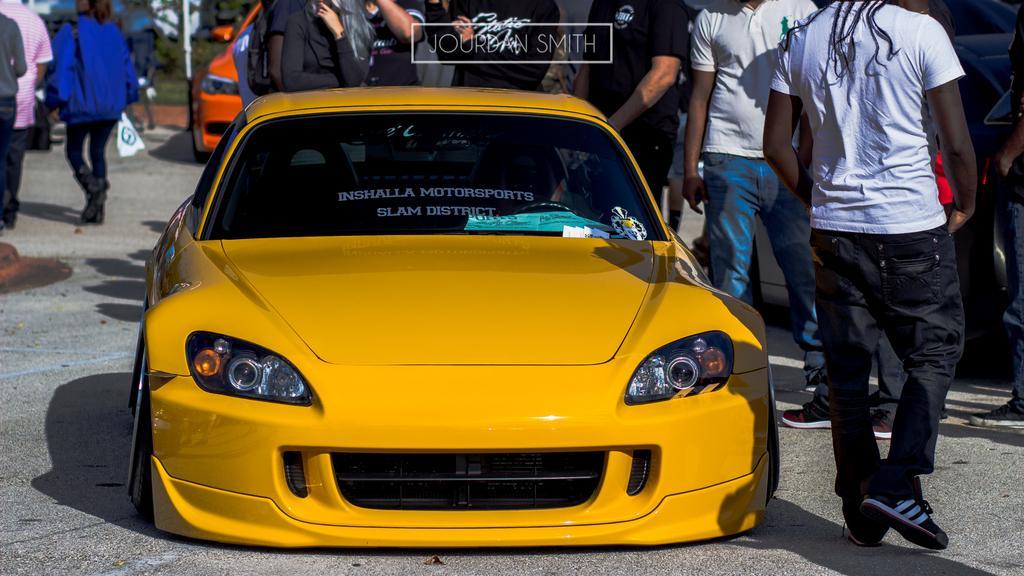Can you describe this image briefly? In this image there is a road, on the road there are two vehicles , group of persons text visible at the top , in the foreground there is a text visible at the top of it , there is a pole visible in the middle 